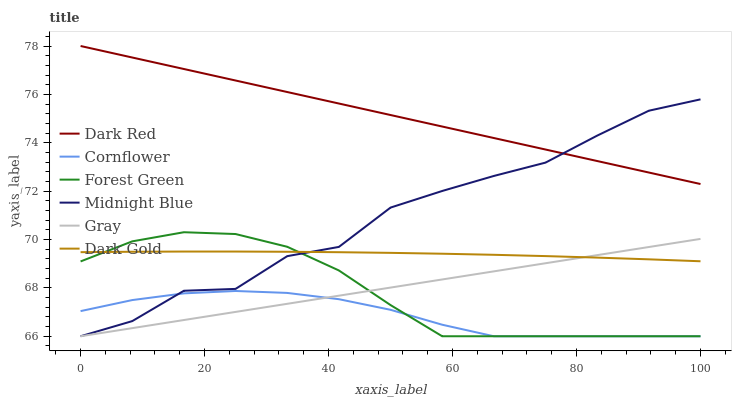Does Cornflower have the minimum area under the curve?
Answer yes or no. Yes. Does Dark Red have the maximum area under the curve?
Answer yes or no. Yes. Does Midnight Blue have the minimum area under the curve?
Answer yes or no. No. Does Midnight Blue have the maximum area under the curve?
Answer yes or no. No. Is Gray the smoothest?
Answer yes or no. Yes. Is Midnight Blue the roughest?
Answer yes or no. Yes. Is Dark Gold the smoothest?
Answer yes or no. No. Is Dark Gold the roughest?
Answer yes or no. No. Does Gray have the lowest value?
Answer yes or no. Yes. Does Dark Gold have the lowest value?
Answer yes or no. No. Does Dark Red have the highest value?
Answer yes or no. Yes. Does Midnight Blue have the highest value?
Answer yes or no. No. Is Dark Gold less than Dark Red?
Answer yes or no. Yes. Is Dark Red greater than Forest Green?
Answer yes or no. Yes. Does Forest Green intersect Midnight Blue?
Answer yes or no. Yes. Is Forest Green less than Midnight Blue?
Answer yes or no. No. Is Forest Green greater than Midnight Blue?
Answer yes or no. No. Does Dark Gold intersect Dark Red?
Answer yes or no. No. 